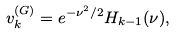Convert formula to latex. <formula><loc_0><loc_0><loc_500><loc_500>v _ { k } ^ { ( G ) } = e ^ { - \nu ^ { 2 } / 2 } H _ { k - 1 } ( \nu ) ,</formula> 